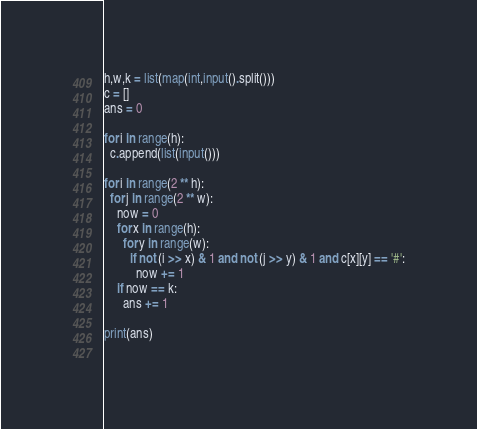<code> <loc_0><loc_0><loc_500><loc_500><_Python_>h,w,k = list(map(int,input().split()))
c = []
ans = 0

for i in range(h):
  c.append(list(input()))

for i in range(2 ** h):
  for j in range(2 ** w):
    now = 0
    for x in range(h):
      for y in range(w):
        if not (i >> x) & 1 and not (j >> y) & 1 and c[x][y] == '#':
          now += 1
    if now == k:
      ans += 1

print(ans)
          

</code> 